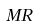Convert formula to latex. <formula><loc_0><loc_0><loc_500><loc_500>M R</formula> 